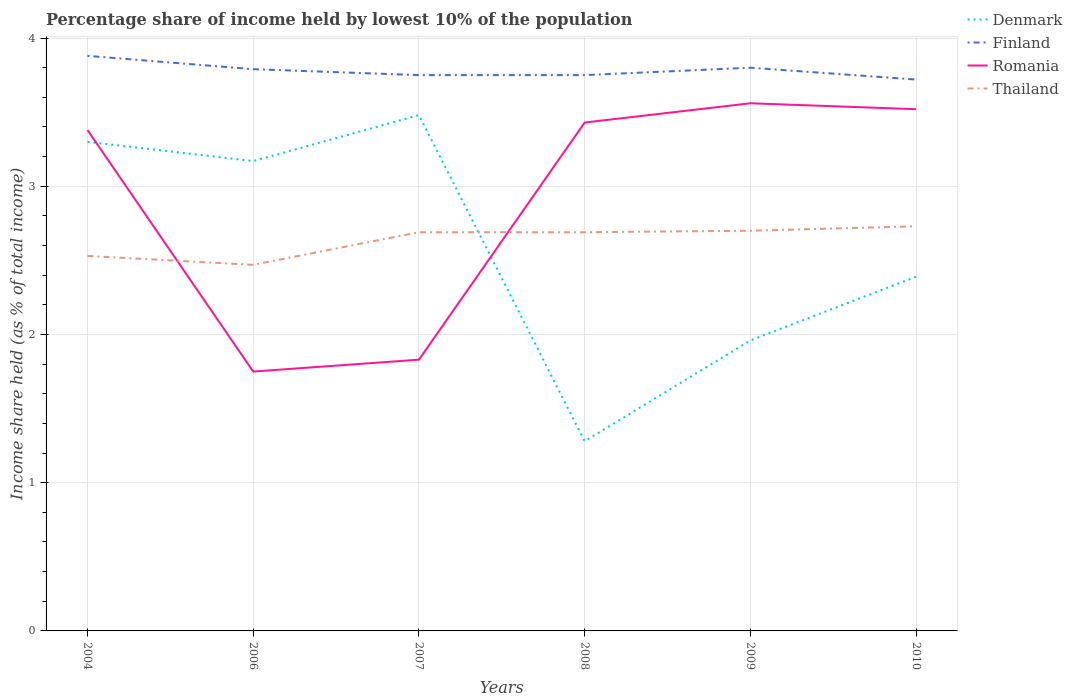Does the line corresponding to Finland intersect with the line corresponding to Romania?
Provide a succinct answer. No. Is the number of lines equal to the number of legend labels?
Provide a succinct answer. Yes. Across all years, what is the maximum percentage share of income held by lowest 10% of the population in Thailand?
Your answer should be very brief. 2.47. In which year was the percentage share of income held by lowest 10% of the population in Finland maximum?
Provide a short and direct response. 2010. What is the total percentage share of income held by lowest 10% of the population in Thailand in the graph?
Offer a very short reply. -0.22. What is the difference between the highest and the second highest percentage share of income held by lowest 10% of the population in Romania?
Offer a terse response. 1.81. How many lines are there?
Give a very brief answer. 4. Are the values on the major ticks of Y-axis written in scientific E-notation?
Provide a succinct answer. No. Does the graph contain any zero values?
Give a very brief answer. No. How many legend labels are there?
Your answer should be very brief. 4. How are the legend labels stacked?
Ensure brevity in your answer.  Vertical. What is the title of the graph?
Your answer should be very brief. Percentage share of income held by lowest 10% of the population. What is the label or title of the Y-axis?
Offer a very short reply. Income share held (as % of total income). What is the Income share held (as % of total income) of Denmark in 2004?
Offer a terse response. 3.3. What is the Income share held (as % of total income) of Finland in 2004?
Offer a very short reply. 3.88. What is the Income share held (as % of total income) in Romania in 2004?
Ensure brevity in your answer.  3.38. What is the Income share held (as % of total income) in Thailand in 2004?
Offer a very short reply. 2.53. What is the Income share held (as % of total income) in Denmark in 2006?
Offer a very short reply. 3.17. What is the Income share held (as % of total income) in Finland in 2006?
Your answer should be very brief. 3.79. What is the Income share held (as % of total income) of Thailand in 2006?
Ensure brevity in your answer.  2.47. What is the Income share held (as % of total income) of Denmark in 2007?
Provide a short and direct response. 3.48. What is the Income share held (as % of total income) of Finland in 2007?
Provide a short and direct response. 3.75. What is the Income share held (as % of total income) in Romania in 2007?
Keep it short and to the point. 1.83. What is the Income share held (as % of total income) in Thailand in 2007?
Give a very brief answer. 2.69. What is the Income share held (as % of total income) of Denmark in 2008?
Your response must be concise. 1.28. What is the Income share held (as % of total income) of Finland in 2008?
Ensure brevity in your answer.  3.75. What is the Income share held (as % of total income) of Romania in 2008?
Offer a very short reply. 3.43. What is the Income share held (as % of total income) in Thailand in 2008?
Your answer should be compact. 2.69. What is the Income share held (as % of total income) of Denmark in 2009?
Offer a terse response. 1.96. What is the Income share held (as % of total income) of Romania in 2009?
Provide a succinct answer. 3.56. What is the Income share held (as % of total income) in Thailand in 2009?
Your response must be concise. 2.7. What is the Income share held (as % of total income) of Denmark in 2010?
Keep it short and to the point. 2.39. What is the Income share held (as % of total income) in Finland in 2010?
Give a very brief answer. 3.72. What is the Income share held (as % of total income) of Romania in 2010?
Offer a very short reply. 3.52. What is the Income share held (as % of total income) in Thailand in 2010?
Your answer should be very brief. 2.73. Across all years, what is the maximum Income share held (as % of total income) in Denmark?
Provide a succinct answer. 3.48. Across all years, what is the maximum Income share held (as % of total income) of Finland?
Ensure brevity in your answer.  3.88. Across all years, what is the maximum Income share held (as % of total income) in Romania?
Give a very brief answer. 3.56. Across all years, what is the maximum Income share held (as % of total income) in Thailand?
Offer a terse response. 2.73. Across all years, what is the minimum Income share held (as % of total income) in Denmark?
Your response must be concise. 1.28. Across all years, what is the minimum Income share held (as % of total income) of Finland?
Provide a succinct answer. 3.72. Across all years, what is the minimum Income share held (as % of total income) of Thailand?
Your answer should be very brief. 2.47. What is the total Income share held (as % of total income) in Denmark in the graph?
Give a very brief answer. 15.58. What is the total Income share held (as % of total income) in Finland in the graph?
Keep it short and to the point. 22.69. What is the total Income share held (as % of total income) in Romania in the graph?
Provide a short and direct response. 17.47. What is the total Income share held (as % of total income) in Thailand in the graph?
Offer a terse response. 15.81. What is the difference between the Income share held (as % of total income) in Denmark in 2004 and that in 2006?
Ensure brevity in your answer.  0.13. What is the difference between the Income share held (as % of total income) of Finland in 2004 and that in 2006?
Provide a succinct answer. 0.09. What is the difference between the Income share held (as % of total income) in Romania in 2004 and that in 2006?
Your answer should be compact. 1.63. What is the difference between the Income share held (as % of total income) of Denmark in 2004 and that in 2007?
Give a very brief answer. -0.18. What is the difference between the Income share held (as % of total income) of Finland in 2004 and that in 2007?
Offer a terse response. 0.13. What is the difference between the Income share held (as % of total income) of Romania in 2004 and that in 2007?
Provide a succinct answer. 1.55. What is the difference between the Income share held (as % of total income) in Thailand in 2004 and that in 2007?
Your response must be concise. -0.16. What is the difference between the Income share held (as % of total income) of Denmark in 2004 and that in 2008?
Your answer should be compact. 2.02. What is the difference between the Income share held (as % of total income) in Finland in 2004 and that in 2008?
Offer a terse response. 0.13. What is the difference between the Income share held (as % of total income) in Romania in 2004 and that in 2008?
Your response must be concise. -0.05. What is the difference between the Income share held (as % of total income) of Thailand in 2004 and that in 2008?
Offer a terse response. -0.16. What is the difference between the Income share held (as % of total income) of Denmark in 2004 and that in 2009?
Offer a very short reply. 1.34. What is the difference between the Income share held (as % of total income) in Romania in 2004 and that in 2009?
Ensure brevity in your answer.  -0.18. What is the difference between the Income share held (as % of total income) of Thailand in 2004 and that in 2009?
Give a very brief answer. -0.17. What is the difference between the Income share held (as % of total income) of Denmark in 2004 and that in 2010?
Provide a short and direct response. 0.91. What is the difference between the Income share held (as % of total income) of Finland in 2004 and that in 2010?
Keep it short and to the point. 0.16. What is the difference between the Income share held (as % of total income) of Romania in 2004 and that in 2010?
Keep it short and to the point. -0.14. What is the difference between the Income share held (as % of total income) of Denmark in 2006 and that in 2007?
Give a very brief answer. -0.31. What is the difference between the Income share held (as % of total income) of Finland in 2006 and that in 2007?
Offer a very short reply. 0.04. What is the difference between the Income share held (as % of total income) of Romania in 2006 and that in 2007?
Provide a short and direct response. -0.08. What is the difference between the Income share held (as % of total income) of Thailand in 2006 and that in 2007?
Provide a short and direct response. -0.22. What is the difference between the Income share held (as % of total income) in Denmark in 2006 and that in 2008?
Keep it short and to the point. 1.89. What is the difference between the Income share held (as % of total income) of Finland in 2006 and that in 2008?
Your response must be concise. 0.04. What is the difference between the Income share held (as % of total income) in Romania in 2006 and that in 2008?
Your answer should be very brief. -1.68. What is the difference between the Income share held (as % of total income) of Thailand in 2006 and that in 2008?
Offer a very short reply. -0.22. What is the difference between the Income share held (as % of total income) in Denmark in 2006 and that in 2009?
Your response must be concise. 1.21. What is the difference between the Income share held (as % of total income) in Finland in 2006 and that in 2009?
Provide a succinct answer. -0.01. What is the difference between the Income share held (as % of total income) in Romania in 2006 and that in 2009?
Keep it short and to the point. -1.81. What is the difference between the Income share held (as % of total income) in Thailand in 2006 and that in 2009?
Ensure brevity in your answer.  -0.23. What is the difference between the Income share held (as % of total income) in Denmark in 2006 and that in 2010?
Make the answer very short. 0.78. What is the difference between the Income share held (as % of total income) of Finland in 2006 and that in 2010?
Provide a succinct answer. 0.07. What is the difference between the Income share held (as % of total income) of Romania in 2006 and that in 2010?
Offer a very short reply. -1.77. What is the difference between the Income share held (as % of total income) of Thailand in 2006 and that in 2010?
Offer a terse response. -0.26. What is the difference between the Income share held (as % of total income) in Denmark in 2007 and that in 2008?
Provide a succinct answer. 2.2. What is the difference between the Income share held (as % of total income) of Romania in 2007 and that in 2008?
Make the answer very short. -1.6. What is the difference between the Income share held (as % of total income) in Denmark in 2007 and that in 2009?
Ensure brevity in your answer.  1.52. What is the difference between the Income share held (as % of total income) of Finland in 2007 and that in 2009?
Provide a succinct answer. -0.05. What is the difference between the Income share held (as % of total income) in Romania in 2007 and that in 2009?
Provide a succinct answer. -1.73. What is the difference between the Income share held (as % of total income) in Thailand in 2007 and that in 2009?
Your response must be concise. -0.01. What is the difference between the Income share held (as % of total income) in Denmark in 2007 and that in 2010?
Provide a short and direct response. 1.09. What is the difference between the Income share held (as % of total income) of Romania in 2007 and that in 2010?
Provide a succinct answer. -1.69. What is the difference between the Income share held (as % of total income) of Thailand in 2007 and that in 2010?
Make the answer very short. -0.04. What is the difference between the Income share held (as % of total income) in Denmark in 2008 and that in 2009?
Give a very brief answer. -0.68. What is the difference between the Income share held (as % of total income) in Finland in 2008 and that in 2009?
Your answer should be very brief. -0.05. What is the difference between the Income share held (as % of total income) in Romania in 2008 and that in 2009?
Provide a succinct answer. -0.13. What is the difference between the Income share held (as % of total income) of Thailand in 2008 and that in 2009?
Keep it short and to the point. -0.01. What is the difference between the Income share held (as % of total income) in Denmark in 2008 and that in 2010?
Provide a succinct answer. -1.11. What is the difference between the Income share held (as % of total income) in Romania in 2008 and that in 2010?
Make the answer very short. -0.09. What is the difference between the Income share held (as % of total income) of Thailand in 2008 and that in 2010?
Give a very brief answer. -0.04. What is the difference between the Income share held (as % of total income) in Denmark in 2009 and that in 2010?
Offer a very short reply. -0.43. What is the difference between the Income share held (as % of total income) in Thailand in 2009 and that in 2010?
Offer a very short reply. -0.03. What is the difference between the Income share held (as % of total income) in Denmark in 2004 and the Income share held (as % of total income) in Finland in 2006?
Offer a terse response. -0.49. What is the difference between the Income share held (as % of total income) in Denmark in 2004 and the Income share held (as % of total income) in Romania in 2006?
Keep it short and to the point. 1.55. What is the difference between the Income share held (as % of total income) in Denmark in 2004 and the Income share held (as % of total income) in Thailand in 2006?
Offer a terse response. 0.83. What is the difference between the Income share held (as % of total income) of Finland in 2004 and the Income share held (as % of total income) of Romania in 2006?
Ensure brevity in your answer.  2.13. What is the difference between the Income share held (as % of total income) in Finland in 2004 and the Income share held (as % of total income) in Thailand in 2006?
Your answer should be very brief. 1.41. What is the difference between the Income share held (as % of total income) in Romania in 2004 and the Income share held (as % of total income) in Thailand in 2006?
Keep it short and to the point. 0.91. What is the difference between the Income share held (as % of total income) of Denmark in 2004 and the Income share held (as % of total income) of Finland in 2007?
Provide a succinct answer. -0.45. What is the difference between the Income share held (as % of total income) in Denmark in 2004 and the Income share held (as % of total income) in Romania in 2007?
Provide a succinct answer. 1.47. What is the difference between the Income share held (as % of total income) of Denmark in 2004 and the Income share held (as % of total income) of Thailand in 2007?
Provide a short and direct response. 0.61. What is the difference between the Income share held (as % of total income) of Finland in 2004 and the Income share held (as % of total income) of Romania in 2007?
Provide a short and direct response. 2.05. What is the difference between the Income share held (as % of total income) of Finland in 2004 and the Income share held (as % of total income) of Thailand in 2007?
Ensure brevity in your answer.  1.19. What is the difference between the Income share held (as % of total income) in Romania in 2004 and the Income share held (as % of total income) in Thailand in 2007?
Your answer should be very brief. 0.69. What is the difference between the Income share held (as % of total income) in Denmark in 2004 and the Income share held (as % of total income) in Finland in 2008?
Make the answer very short. -0.45. What is the difference between the Income share held (as % of total income) in Denmark in 2004 and the Income share held (as % of total income) in Romania in 2008?
Your answer should be very brief. -0.13. What is the difference between the Income share held (as % of total income) in Denmark in 2004 and the Income share held (as % of total income) in Thailand in 2008?
Ensure brevity in your answer.  0.61. What is the difference between the Income share held (as % of total income) of Finland in 2004 and the Income share held (as % of total income) of Romania in 2008?
Provide a succinct answer. 0.45. What is the difference between the Income share held (as % of total income) in Finland in 2004 and the Income share held (as % of total income) in Thailand in 2008?
Keep it short and to the point. 1.19. What is the difference between the Income share held (as % of total income) in Romania in 2004 and the Income share held (as % of total income) in Thailand in 2008?
Give a very brief answer. 0.69. What is the difference between the Income share held (as % of total income) of Denmark in 2004 and the Income share held (as % of total income) of Romania in 2009?
Offer a terse response. -0.26. What is the difference between the Income share held (as % of total income) of Finland in 2004 and the Income share held (as % of total income) of Romania in 2009?
Offer a terse response. 0.32. What is the difference between the Income share held (as % of total income) in Finland in 2004 and the Income share held (as % of total income) in Thailand in 2009?
Your answer should be compact. 1.18. What is the difference between the Income share held (as % of total income) of Romania in 2004 and the Income share held (as % of total income) of Thailand in 2009?
Provide a succinct answer. 0.68. What is the difference between the Income share held (as % of total income) of Denmark in 2004 and the Income share held (as % of total income) of Finland in 2010?
Ensure brevity in your answer.  -0.42. What is the difference between the Income share held (as % of total income) of Denmark in 2004 and the Income share held (as % of total income) of Romania in 2010?
Provide a succinct answer. -0.22. What is the difference between the Income share held (as % of total income) in Denmark in 2004 and the Income share held (as % of total income) in Thailand in 2010?
Keep it short and to the point. 0.57. What is the difference between the Income share held (as % of total income) in Finland in 2004 and the Income share held (as % of total income) in Romania in 2010?
Provide a short and direct response. 0.36. What is the difference between the Income share held (as % of total income) of Finland in 2004 and the Income share held (as % of total income) of Thailand in 2010?
Provide a short and direct response. 1.15. What is the difference between the Income share held (as % of total income) in Romania in 2004 and the Income share held (as % of total income) in Thailand in 2010?
Provide a succinct answer. 0.65. What is the difference between the Income share held (as % of total income) of Denmark in 2006 and the Income share held (as % of total income) of Finland in 2007?
Offer a terse response. -0.58. What is the difference between the Income share held (as % of total income) in Denmark in 2006 and the Income share held (as % of total income) in Romania in 2007?
Your answer should be compact. 1.34. What is the difference between the Income share held (as % of total income) of Denmark in 2006 and the Income share held (as % of total income) of Thailand in 2007?
Give a very brief answer. 0.48. What is the difference between the Income share held (as % of total income) in Finland in 2006 and the Income share held (as % of total income) in Romania in 2007?
Your answer should be compact. 1.96. What is the difference between the Income share held (as % of total income) of Finland in 2006 and the Income share held (as % of total income) of Thailand in 2007?
Make the answer very short. 1.1. What is the difference between the Income share held (as % of total income) of Romania in 2006 and the Income share held (as % of total income) of Thailand in 2007?
Your answer should be compact. -0.94. What is the difference between the Income share held (as % of total income) in Denmark in 2006 and the Income share held (as % of total income) in Finland in 2008?
Provide a succinct answer. -0.58. What is the difference between the Income share held (as % of total income) of Denmark in 2006 and the Income share held (as % of total income) of Romania in 2008?
Provide a short and direct response. -0.26. What is the difference between the Income share held (as % of total income) of Denmark in 2006 and the Income share held (as % of total income) of Thailand in 2008?
Keep it short and to the point. 0.48. What is the difference between the Income share held (as % of total income) in Finland in 2006 and the Income share held (as % of total income) in Romania in 2008?
Your response must be concise. 0.36. What is the difference between the Income share held (as % of total income) of Finland in 2006 and the Income share held (as % of total income) of Thailand in 2008?
Your answer should be very brief. 1.1. What is the difference between the Income share held (as % of total income) of Romania in 2006 and the Income share held (as % of total income) of Thailand in 2008?
Ensure brevity in your answer.  -0.94. What is the difference between the Income share held (as % of total income) in Denmark in 2006 and the Income share held (as % of total income) in Finland in 2009?
Your response must be concise. -0.63. What is the difference between the Income share held (as % of total income) in Denmark in 2006 and the Income share held (as % of total income) in Romania in 2009?
Your answer should be very brief. -0.39. What is the difference between the Income share held (as % of total income) in Denmark in 2006 and the Income share held (as % of total income) in Thailand in 2009?
Give a very brief answer. 0.47. What is the difference between the Income share held (as % of total income) of Finland in 2006 and the Income share held (as % of total income) of Romania in 2009?
Provide a short and direct response. 0.23. What is the difference between the Income share held (as % of total income) of Finland in 2006 and the Income share held (as % of total income) of Thailand in 2009?
Keep it short and to the point. 1.09. What is the difference between the Income share held (as % of total income) of Romania in 2006 and the Income share held (as % of total income) of Thailand in 2009?
Keep it short and to the point. -0.95. What is the difference between the Income share held (as % of total income) in Denmark in 2006 and the Income share held (as % of total income) in Finland in 2010?
Keep it short and to the point. -0.55. What is the difference between the Income share held (as % of total income) of Denmark in 2006 and the Income share held (as % of total income) of Romania in 2010?
Your answer should be compact. -0.35. What is the difference between the Income share held (as % of total income) of Denmark in 2006 and the Income share held (as % of total income) of Thailand in 2010?
Provide a short and direct response. 0.44. What is the difference between the Income share held (as % of total income) in Finland in 2006 and the Income share held (as % of total income) in Romania in 2010?
Ensure brevity in your answer.  0.27. What is the difference between the Income share held (as % of total income) in Finland in 2006 and the Income share held (as % of total income) in Thailand in 2010?
Provide a succinct answer. 1.06. What is the difference between the Income share held (as % of total income) of Romania in 2006 and the Income share held (as % of total income) of Thailand in 2010?
Your response must be concise. -0.98. What is the difference between the Income share held (as % of total income) in Denmark in 2007 and the Income share held (as % of total income) in Finland in 2008?
Give a very brief answer. -0.27. What is the difference between the Income share held (as % of total income) of Denmark in 2007 and the Income share held (as % of total income) of Thailand in 2008?
Make the answer very short. 0.79. What is the difference between the Income share held (as % of total income) in Finland in 2007 and the Income share held (as % of total income) in Romania in 2008?
Keep it short and to the point. 0.32. What is the difference between the Income share held (as % of total income) in Finland in 2007 and the Income share held (as % of total income) in Thailand in 2008?
Give a very brief answer. 1.06. What is the difference between the Income share held (as % of total income) in Romania in 2007 and the Income share held (as % of total income) in Thailand in 2008?
Make the answer very short. -0.86. What is the difference between the Income share held (as % of total income) in Denmark in 2007 and the Income share held (as % of total income) in Finland in 2009?
Your answer should be compact. -0.32. What is the difference between the Income share held (as % of total income) in Denmark in 2007 and the Income share held (as % of total income) in Romania in 2009?
Your answer should be compact. -0.08. What is the difference between the Income share held (as % of total income) of Denmark in 2007 and the Income share held (as % of total income) of Thailand in 2009?
Your answer should be compact. 0.78. What is the difference between the Income share held (as % of total income) in Finland in 2007 and the Income share held (as % of total income) in Romania in 2009?
Make the answer very short. 0.19. What is the difference between the Income share held (as % of total income) of Finland in 2007 and the Income share held (as % of total income) of Thailand in 2009?
Ensure brevity in your answer.  1.05. What is the difference between the Income share held (as % of total income) in Romania in 2007 and the Income share held (as % of total income) in Thailand in 2009?
Provide a succinct answer. -0.87. What is the difference between the Income share held (as % of total income) of Denmark in 2007 and the Income share held (as % of total income) of Finland in 2010?
Provide a succinct answer. -0.24. What is the difference between the Income share held (as % of total income) in Denmark in 2007 and the Income share held (as % of total income) in Romania in 2010?
Offer a very short reply. -0.04. What is the difference between the Income share held (as % of total income) of Denmark in 2007 and the Income share held (as % of total income) of Thailand in 2010?
Offer a terse response. 0.75. What is the difference between the Income share held (as % of total income) of Finland in 2007 and the Income share held (as % of total income) of Romania in 2010?
Provide a succinct answer. 0.23. What is the difference between the Income share held (as % of total income) in Romania in 2007 and the Income share held (as % of total income) in Thailand in 2010?
Your answer should be compact. -0.9. What is the difference between the Income share held (as % of total income) of Denmark in 2008 and the Income share held (as % of total income) of Finland in 2009?
Your response must be concise. -2.52. What is the difference between the Income share held (as % of total income) of Denmark in 2008 and the Income share held (as % of total income) of Romania in 2009?
Your answer should be compact. -2.28. What is the difference between the Income share held (as % of total income) of Denmark in 2008 and the Income share held (as % of total income) of Thailand in 2009?
Your answer should be very brief. -1.42. What is the difference between the Income share held (as % of total income) of Finland in 2008 and the Income share held (as % of total income) of Romania in 2009?
Keep it short and to the point. 0.19. What is the difference between the Income share held (as % of total income) of Romania in 2008 and the Income share held (as % of total income) of Thailand in 2009?
Offer a terse response. 0.73. What is the difference between the Income share held (as % of total income) in Denmark in 2008 and the Income share held (as % of total income) in Finland in 2010?
Ensure brevity in your answer.  -2.44. What is the difference between the Income share held (as % of total income) in Denmark in 2008 and the Income share held (as % of total income) in Romania in 2010?
Offer a terse response. -2.24. What is the difference between the Income share held (as % of total income) of Denmark in 2008 and the Income share held (as % of total income) of Thailand in 2010?
Offer a terse response. -1.45. What is the difference between the Income share held (as % of total income) in Finland in 2008 and the Income share held (as % of total income) in Romania in 2010?
Offer a terse response. 0.23. What is the difference between the Income share held (as % of total income) of Romania in 2008 and the Income share held (as % of total income) of Thailand in 2010?
Your response must be concise. 0.7. What is the difference between the Income share held (as % of total income) in Denmark in 2009 and the Income share held (as % of total income) in Finland in 2010?
Provide a succinct answer. -1.76. What is the difference between the Income share held (as % of total income) of Denmark in 2009 and the Income share held (as % of total income) of Romania in 2010?
Provide a succinct answer. -1.56. What is the difference between the Income share held (as % of total income) in Denmark in 2009 and the Income share held (as % of total income) in Thailand in 2010?
Offer a terse response. -0.77. What is the difference between the Income share held (as % of total income) of Finland in 2009 and the Income share held (as % of total income) of Romania in 2010?
Ensure brevity in your answer.  0.28. What is the difference between the Income share held (as % of total income) in Finland in 2009 and the Income share held (as % of total income) in Thailand in 2010?
Make the answer very short. 1.07. What is the difference between the Income share held (as % of total income) of Romania in 2009 and the Income share held (as % of total income) of Thailand in 2010?
Your answer should be compact. 0.83. What is the average Income share held (as % of total income) in Denmark per year?
Provide a short and direct response. 2.6. What is the average Income share held (as % of total income) in Finland per year?
Provide a succinct answer. 3.78. What is the average Income share held (as % of total income) in Romania per year?
Give a very brief answer. 2.91. What is the average Income share held (as % of total income) of Thailand per year?
Your response must be concise. 2.63. In the year 2004, what is the difference between the Income share held (as % of total income) of Denmark and Income share held (as % of total income) of Finland?
Keep it short and to the point. -0.58. In the year 2004, what is the difference between the Income share held (as % of total income) in Denmark and Income share held (as % of total income) in Romania?
Keep it short and to the point. -0.08. In the year 2004, what is the difference between the Income share held (as % of total income) of Denmark and Income share held (as % of total income) of Thailand?
Keep it short and to the point. 0.77. In the year 2004, what is the difference between the Income share held (as % of total income) in Finland and Income share held (as % of total income) in Romania?
Make the answer very short. 0.5. In the year 2004, what is the difference between the Income share held (as % of total income) in Finland and Income share held (as % of total income) in Thailand?
Make the answer very short. 1.35. In the year 2006, what is the difference between the Income share held (as % of total income) in Denmark and Income share held (as % of total income) in Finland?
Ensure brevity in your answer.  -0.62. In the year 2006, what is the difference between the Income share held (as % of total income) of Denmark and Income share held (as % of total income) of Romania?
Make the answer very short. 1.42. In the year 2006, what is the difference between the Income share held (as % of total income) in Denmark and Income share held (as % of total income) in Thailand?
Your answer should be compact. 0.7. In the year 2006, what is the difference between the Income share held (as % of total income) of Finland and Income share held (as % of total income) of Romania?
Keep it short and to the point. 2.04. In the year 2006, what is the difference between the Income share held (as % of total income) of Finland and Income share held (as % of total income) of Thailand?
Provide a short and direct response. 1.32. In the year 2006, what is the difference between the Income share held (as % of total income) of Romania and Income share held (as % of total income) of Thailand?
Keep it short and to the point. -0.72. In the year 2007, what is the difference between the Income share held (as % of total income) of Denmark and Income share held (as % of total income) of Finland?
Provide a short and direct response. -0.27. In the year 2007, what is the difference between the Income share held (as % of total income) of Denmark and Income share held (as % of total income) of Romania?
Give a very brief answer. 1.65. In the year 2007, what is the difference between the Income share held (as % of total income) of Denmark and Income share held (as % of total income) of Thailand?
Your answer should be very brief. 0.79. In the year 2007, what is the difference between the Income share held (as % of total income) in Finland and Income share held (as % of total income) in Romania?
Offer a terse response. 1.92. In the year 2007, what is the difference between the Income share held (as % of total income) of Finland and Income share held (as % of total income) of Thailand?
Make the answer very short. 1.06. In the year 2007, what is the difference between the Income share held (as % of total income) of Romania and Income share held (as % of total income) of Thailand?
Give a very brief answer. -0.86. In the year 2008, what is the difference between the Income share held (as % of total income) in Denmark and Income share held (as % of total income) in Finland?
Your answer should be compact. -2.47. In the year 2008, what is the difference between the Income share held (as % of total income) in Denmark and Income share held (as % of total income) in Romania?
Ensure brevity in your answer.  -2.15. In the year 2008, what is the difference between the Income share held (as % of total income) in Denmark and Income share held (as % of total income) in Thailand?
Your answer should be very brief. -1.41. In the year 2008, what is the difference between the Income share held (as % of total income) in Finland and Income share held (as % of total income) in Romania?
Your answer should be very brief. 0.32. In the year 2008, what is the difference between the Income share held (as % of total income) in Finland and Income share held (as % of total income) in Thailand?
Provide a short and direct response. 1.06. In the year 2008, what is the difference between the Income share held (as % of total income) of Romania and Income share held (as % of total income) of Thailand?
Your response must be concise. 0.74. In the year 2009, what is the difference between the Income share held (as % of total income) of Denmark and Income share held (as % of total income) of Finland?
Give a very brief answer. -1.84. In the year 2009, what is the difference between the Income share held (as % of total income) of Denmark and Income share held (as % of total income) of Romania?
Your answer should be compact. -1.6. In the year 2009, what is the difference between the Income share held (as % of total income) of Denmark and Income share held (as % of total income) of Thailand?
Give a very brief answer. -0.74. In the year 2009, what is the difference between the Income share held (as % of total income) in Finland and Income share held (as % of total income) in Romania?
Make the answer very short. 0.24. In the year 2009, what is the difference between the Income share held (as % of total income) in Finland and Income share held (as % of total income) in Thailand?
Provide a succinct answer. 1.1. In the year 2009, what is the difference between the Income share held (as % of total income) of Romania and Income share held (as % of total income) of Thailand?
Keep it short and to the point. 0.86. In the year 2010, what is the difference between the Income share held (as % of total income) in Denmark and Income share held (as % of total income) in Finland?
Your answer should be compact. -1.33. In the year 2010, what is the difference between the Income share held (as % of total income) in Denmark and Income share held (as % of total income) in Romania?
Give a very brief answer. -1.13. In the year 2010, what is the difference between the Income share held (as % of total income) of Denmark and Income share held (as % of total income) of Thailand?
Give a very brief answer. -0.34. In the year 2010, what is the difference between the Income share held (as % of total income) of Finland and Income share held (as % of total income) of Romania?
Your answer should be very brief. 0.2. In the year 2010, what is the difference between the Income share held (as % of total income) of Finland and Income share held (as % of total income) of Thailand?
Your answer should be very brief. 0.99. In the year 2010, what is the difference between the Income share held (as % of total income) in Romania and Income share held (as % of total income) in Thailand?
Offer a very short reply. 0.79. What is the ratio of the Income share held (as % of total income) of Denmark in 2004 to that in 2006?
Your answer should be very brief. 1.04. What is the ratio of the Income share held (as % of total income) in Finland in 2004 to that in 2006?
Ensure brevity in your answer.  1.02. What is the ratio of the Income share held (as % of total income) in Romania in 2004 to that in 2006?
Make the answer very short. 1.93. What is the ratio of the Income share held (as % of total income) in Thailand in 2004 to that in 2006?
Your answer should be compact. 1.02. What is the ratio of the Income share held (as % of total income) in Denmark in 2004 to that in 2007?
Provide a short and direct response. 0.95. What is the ratio of the Income share held (as % of total income) in Finland in 2004 to that in 2007?
Ensure brevity in your answer.  1.03. What is the ratio of the Income share held (as % of total income) of Romania in 2004 to that in 2007?
Your answer should be very brief. 1.85. What is the ratio of the Income share held (as % of total income) in Thailand in 2004 to that in 2007?
Your answer should be compact. 0.94. What is the ratio of the Income share held (as % of total income) in Denmark in 2004 to that in 2008?
Your answer should be very brief. 2.58. What is the ratio of the Income share held (as % of total income) of Finland in 2004 to that in 2008?
Your answer should be compact. 1.03. What is the ratio of the Income share held (as % of total income) of Romania in 2004 to that in 2008?
Make the answer very short. 0.99. What is the ratio of the Income share held (as % of total income) of Thailand in 2004 to that in 2008?
Give a very brief answer. 0.94. What is the ratio of the Income share held (as % of total income) of Denmark in 2004 to that in 2009?
Offer a very short reply. 1.68. What is the ratio of the Income share held (as % of total income) of Finland in 2004 to that in 2009?
Offer a very short reply. 1.02. What is the ratio of the Income share held (as % of total income) in Romania in 2004 to that in 2009?
Make the answer very short. 0.95. What is the ratio of the Income share held (as % of total income) in Thailand in 2004 to that in 2009?
Your answer should be very brief. 0.94. What is the ratio of the Income share held (as % of total income) in Denmark in 2004 to that in 2010?
Offer a terse response. 1.38. What is the ratio of the Income share held (as % of total income) of Finland in 2004 to that in 2010?
Ensure brevity in your answer.  1.04. What is the ratio of the Income share held (as % of total income) of Romania in 2004 to that in 2010?
Give a very brief answer. 0.96. What is the ratio of the Income share held (as % of total income) of Thailand in 2004 to that in 2010?
Make the answer very short. 0.93. What is the ratio of the Income share held (as % of total income) in Denmark in 2006 to that in 2007?
Your answer should be very brief. 0.91. What is the ratio of the Income share held (as % of total income) in Finland in 2006 to that in 2007?
Keep it short and to the point. 1.01. What is the ratio of the Income share held (as % of total income) of Romania in 2006 to that in 2007?
Offer a terse response. 0.96. What is the ratio of the Income share held (as % of total income) of Thailand in 2006 to that in 2007?
Ensure brevity in your answer.  0.92. What is the ratio of the Income share held (as % of total income) in Denmark in 2006 to that in 2008?
Provide a short and direct response. 2.48. What is the ratio of the Income share held (as % of total income) of Finland in 2006 to that in 2008?
Keep it short and to the point. 1.01. What is the ratio of the Income share held (as % of total income) in Romania in 2006 to that in 2008?
Give a very brief answer. 0.51. What is the ratio of the Income share held (as % of total income) of Thailand in 2006 to that in 2008?
Offer a terse response. 0.92. What is the ratio of the Income share held (as % of total income) of Denmark in 2006 to that in 2009?
Your answer should be compact. 1.62. What is the ratio of the Income share held (as % of total income) of Finland in 2006 to that in 2009?
Your answer should be very brief. 1. What is the ratio of the Income share held (as % of total income) in Romania in 2006 to that in 2009?
Provide a succinct answer. 0.49. What is the ratio of the Income share held (as % of total income) of Thailand in 2006 to that in 2009?
Your answer should be compact. 0.91. What is the ratio of the Income share held (as % of total income) of Denmark in 2006 to that in 2010?
Offer a very short reply. 1.33. What is the ratio of the Income share held (as % of total income) in Finland in 2006 to that in 2010?
Your answer should be very brief. 1.02. What is the ratio of the Income share held (as % of total income) in Romania in 2006 to that in 2010?
Provide a short and direct response. 0.5. What is the ratio of the Income share held (as % of total income) of Thailand in 2006 to that in 2010?
Keep it short and to the point. 0.9. What is the ratio of the Income share held (as % of total income) of Denmark in 2007 to that in 2008?
Ensure brevity in your answer.  2.72. What is the ratio of the Income share held (as % of total income) of Romania in 2007 to that in 2008?
Keep it short and to the point. 0.53. What is the ratio of the Income share held (as % of total income) in Thailand in 2007 to that in 2008?
Offer a terse response. 1. What is the ratio of the Income share held (as % of total income) of Denmark in 2007 to that in 2009?
Ensure brevity in your answer.  1.78. What is the ratio of the Income share held (as % of total income) of Finland in 2007 to that in 2009?
Ensure brevity in your answer.  0.99. What is the ratio of the Income share held (as % of total income) in Romania in 2007 to that in 2009?
Offer a very short reply. 0.51. What is the ratio of the Income share held (as % of total income) in Thailand in 2007 to that in 2009?
Your response must be concise. 1. What is the ratio of the Income share held (as % of total income) of Denmark in 2007 to that in 2010?
Give a very brief answer. 1.46. What is the ratio of the Income share held (as % of total income) of Finland in 2007 to that in 2010?
Your answer should be very brief. 1.01. What is the ratio of the Income share held (as % of total income) in Romania in 2007 to that in 2010?
Your answer should be compact. 0.52. What is the ratio of the Income share held (as % of total income) in Thailand in 2007 to that in 2010?
Your answer should be compact. 0.99. What is the ratio of the Income share held (as % of total income) of Denmark in 2008 to that in 2009?
Offer a very short reply. 0.65. What is the ratio of the Income share held (as % of total income) in Romania in 2008 to that in 2009?
Offer a very short reply. 0.96. What is the ratio of the Income share held (as % of total income) of Denmark in 2008 to that in 2010?
Ensure brevity in your answer.  0.54. What is the ratio of the Income share held (as % of total income) in Finland in 2008 to that in 2010?
Provide a short and direct response. 1.01. What is the ratio of the Income share held (as % of total income) of Romania in 2008 to that in 2010?
Keep it short and to the point. 0.97. What is the ratio of the Income share held (as % of total income) of Denmark in 2009 to that in 2010?
Your answer should be very brief. 0.82. What is the ratio of the Income share held (as % of total income) of Finland in 2009 to that in 2010?
Keep it short and to the point. 1.02. What is the ratio of the Income share held (as % of total income) of Romania in 2009 to that in 2010?
Provide a short and direct response. 1.01. What is the ratio of the Income share held (as % of total income) in Thailand in 2009 to that in 2010?
Offer a very short reply. 0.99. What is the difference between the highest and the second highest Income share held (as % of total income) in Denmark?
Give a very brief answer. 0.18. What is the difference between the highest and the second highest Income share held (as % of total income) in Romania?
Your answer should be very brief. 0.04. What is the difference between the highest and the second highest Income share held (as % of total income) of Thailand?
Ensure brevity in your answer.  0.03. What is the difference between the highest and the lowest Income share held (as % of total income) in Denmark?
Ensure brevity in your answer.  2.2. What is the difference between the highest and the lowest Income share held (as % of total income) of Finland?
Your answer should be compact. 0.16. What is the difference between the highest and the lowest Income share held (as % of total income) of Romania?
Ensure brevity in your answer.  1.81. What is the difference between the highest and the lowest Income share held (as % of total income) in Thailand?
Your answer should be compact. 0.26. 